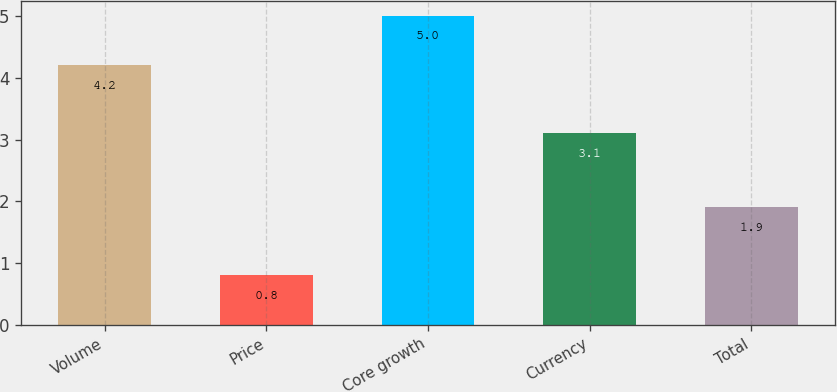<chart> <loc_0><loc_0><loc_500><loc_500><bar_chart><fcel>Volume<fcel>Price<fcel>Core growth<fcel>Currency<fcel>Total<nl><fcel>4.2<fcel>0.8<fcel>5<fcel>3.1<fcel>1.9<nl></chart> 